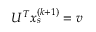Convert formula to latex. <formula><loc_0><loc_0><loc_500><loc_500>U ^ { T } x _ { s } ^ { ( k + 1 ) } = v</formula> 